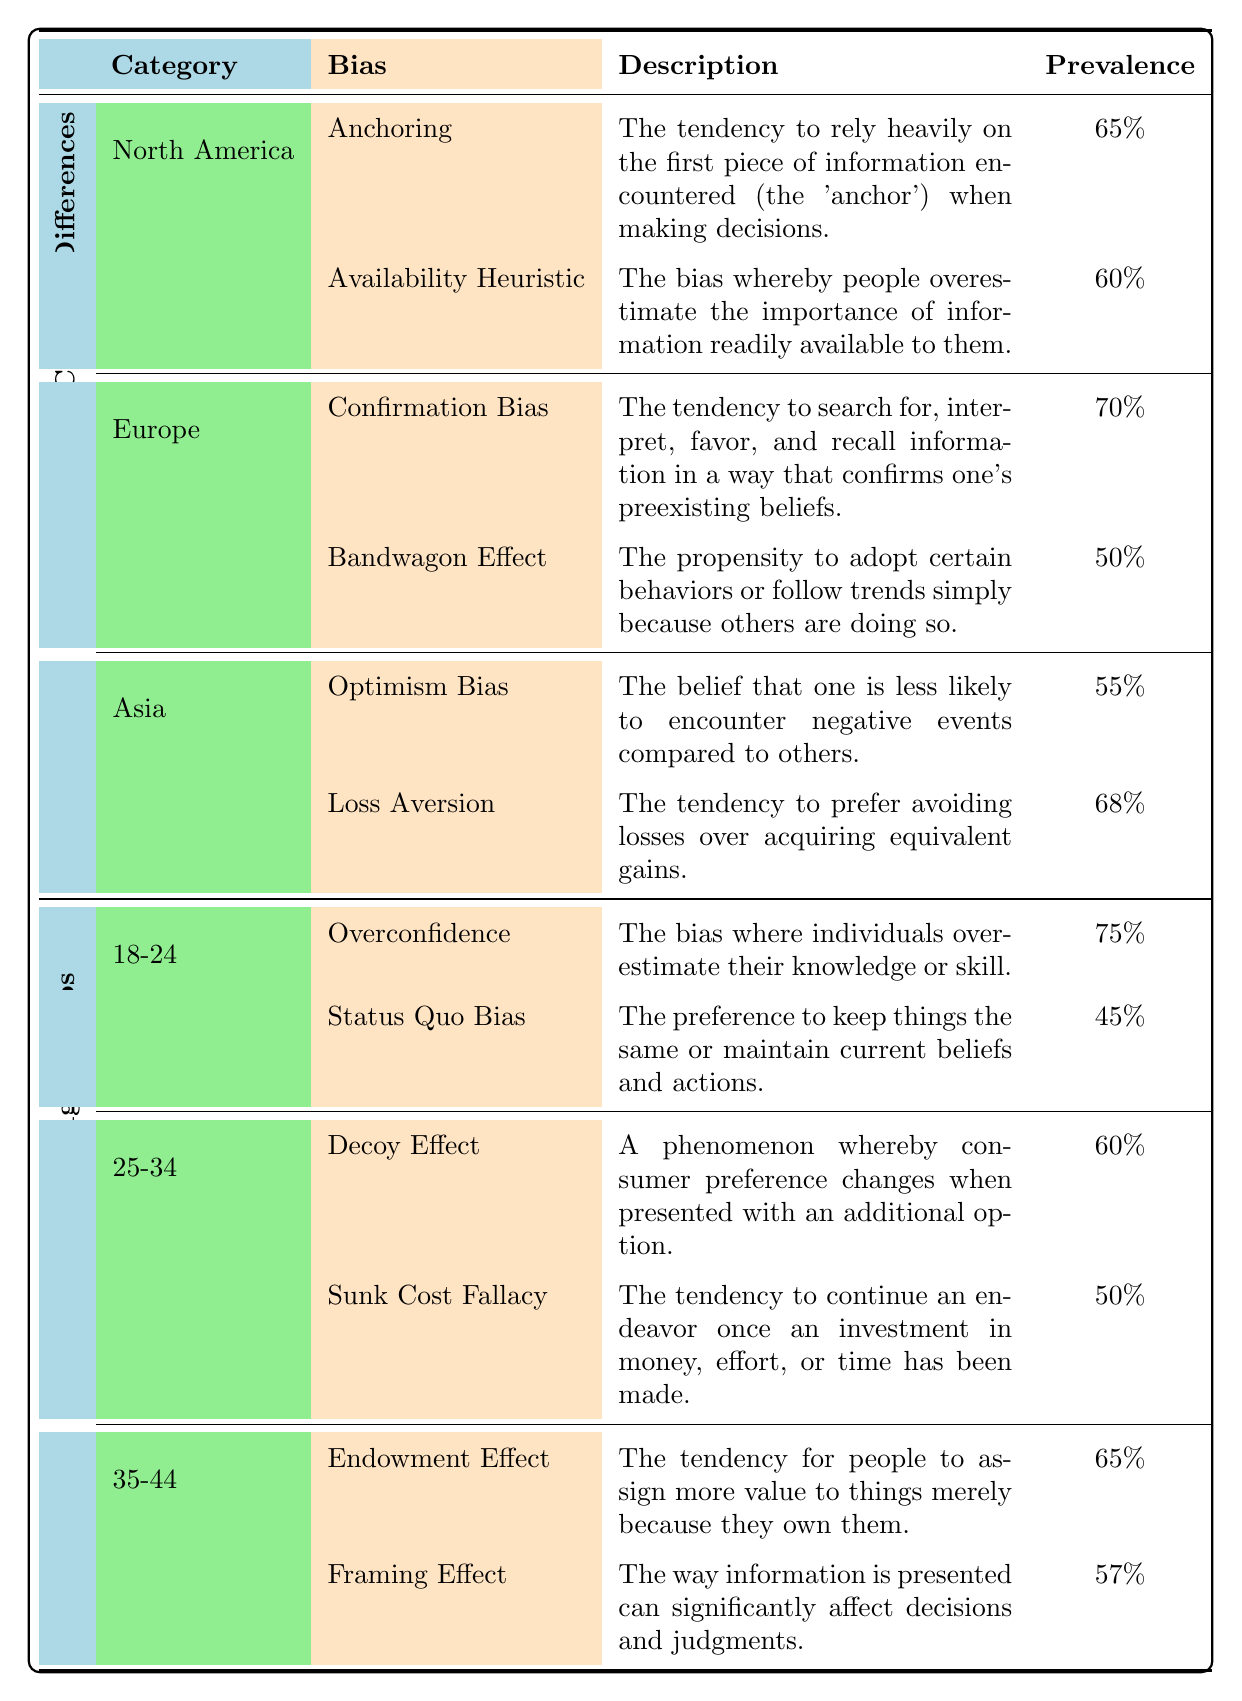What cognitive bias has the highest prevalence rate in the 18-24 age group? The highest prevalence rate in the age group 18-24 is for Overconfidence, which is listed as 75%.
Answer: Overconfidence Which cognitive bias is represented in both North America and Asia? The biases represented in both geographical regions are Anchoring (North America) and Loss Aversion (Asia). However, focusing on their presence and distinct biases, none are the same; this highlights the unique biases per region.
Answer: No common bias What is the average prevalence rate of biases for the age group 25-34? The two biases for this age group are Decoy Effect (60%) and Sunk Cost Fallacy (50%). To find the average, sum the rates: 60 + 50 = 110, and divide by 2, resulting in 55.
Answer: 55 Is the Confirmation Bias more prevalent in Europe than the Availability Heuristic in North America? The prevalence rate for Confirmation Bias in Europe is 70%, and for Availability Heuristic in North America, it is 60%. Since 70 is greater than 60, the Confirmation Bias is indeed more prevalent in Europe.
Answer: Yes What is the difference in prevalence rates between the Endowment Effect and the Loss Aversion biases? The Endowment Effect has a prevalence of 65%, while Loss Aversion has a prevalence of 68%. The difference is calculated by taking the absolute value of 68 minus 65, which is 3.
Answer: 3 